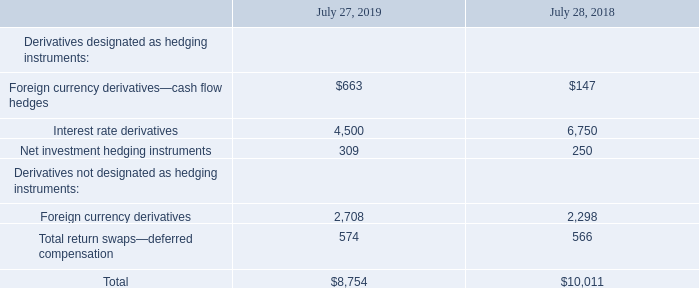12. Derivative Instruments
(a) Summary of Derivative Instruments
We use derivative instruments primarily to manage exposures to foreign currency exchange rate, interest rate, and equity price risks. Our primary objective in holding derivatives is to reduce the volatility of earnings and cash flows associated with changes in foreign currency exchange rates, interest rates, and equity prices. Our derivatives expose us to credit risk to the extent that the counterparties may be unable to meet the terms of the agreement. We do, however, seek to mitigate such risks by limiting our counterparties to major financial institutions. In addition, the potential risk of loss with any one counterparty resulting from this type of credit risk is monitored. Management does not expect material losses as a result of defaults by counterparties.
The notional amounts of our outstanding derivatives are summarized as follows (in millions):
How does the company mitigate credit risk associated with derivatives? By limiting our counterparties to major financial institutions. in addition, the potential risk of loss with any one counterparty resulting from this type of credit risk is monitored. What were the cash flow hedges value in 2019?
Answer scale should be: million. 663. Which years does the table provide information for the company's outstanding derivatives? 2019, 2018. What was the change in the Net investment hedging instruments between 2018 and 2019?
Answer scale should be: million. 309-250
Answer: 59. How many years did foreign currency derivatives exceed $2,000 million? 2019##2018
Answer: 2. What was the percentage change in the total amount of outstanding derivatives between 2018 and 2019?
Answer scale should be: percent. (8,754-10,011)/10,011
Answer: -12.56. 